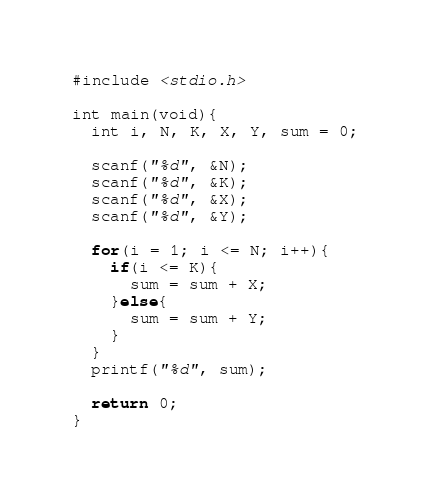<code> <loc_0><loc_0><loc_500><loc_500><_C_>#include <stdio.h>
 
int main(void){
  int i, N, K, X, Y, sum = 0;
  
  scanf("%d", &N);
  scanf("%d", &K);
  scanf("%d", &X);
  scanf("%d", &Y);
  
  for(i = 1; i <= N; i++){
    if(i <= K){
      sum = sum + X;
    }else{
      sum = sum + Y;
    }
  }
  printf("%d", sum);
  
  return 0;
}</code> 